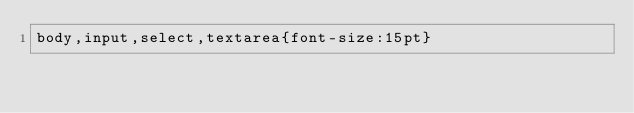Convert code to text. <code><loc_0><loc_0><loc_500><loc_500><_CSS_>body,input,select,textarea{font-size:15pt}</code> 